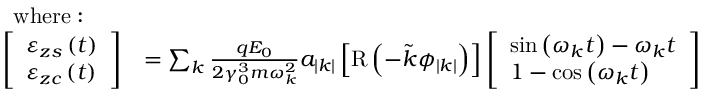Convert formula to latex. <formula><loc_0><loc_0><loc_500><loc_500>\begin{array} { r l } { w h e r e \colon } \\ { \left [ \begin{array} { l } { \varepsilon _ { z s } \left ( t \right ) } \\ { \varepsilon _ { z c } \left ( t \right ) } \end{array} \right ] } & { = \sum _ { k } \frac { q E _ { 0 } } { 2 \gamma _ { 0 } ^ { 3 } m \omega _ { k } ^ { 2 } } a _ { \left | k \right | } \left [ R \left ( - \tilde { k } \phi _ { \left | k \right | } \right ) \right ] \left [ \begin{array} { l } { \sin \left ( \omega _ { k } t \right ) - \omega _ { k } t } \\ { 1 - \cos \left ( \omega _ { k } t \right ) } \end{array} \right ] } \end{array}</formula> 